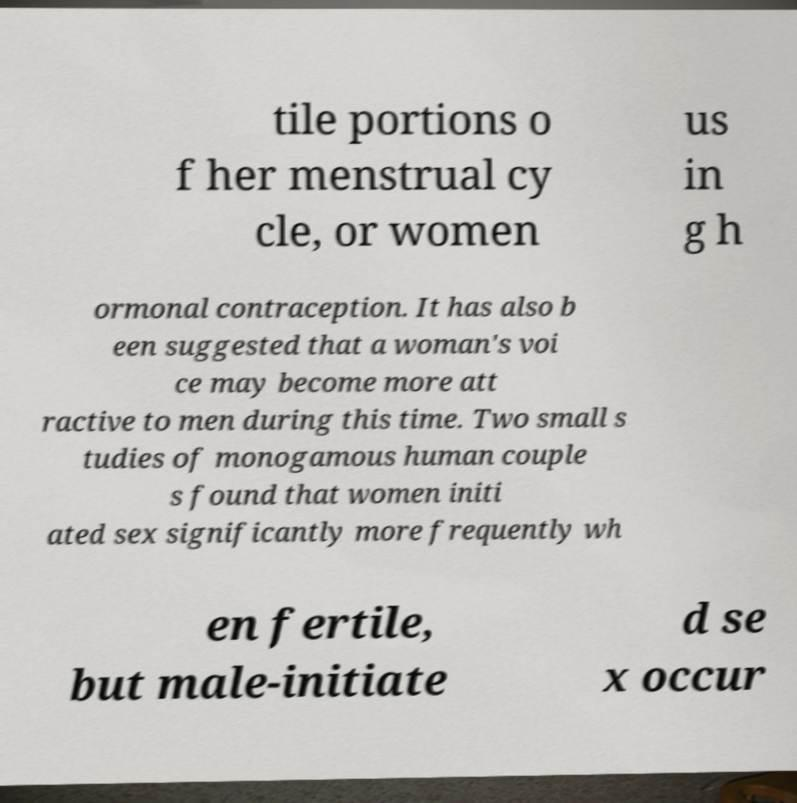There's text embedded in this image that I need extracted. Can you transcribe it verbatim? tile portions o f her menstrual cy cle, or women us in g h ormonal contraception. It has also b een suggested that a woman's voi ce may become more att ractive to men during this time. Two small s tudies of monogamous human couple s found that women initi ated sex significantly more frequently wh en fertile, but male-initiate d se x occur 